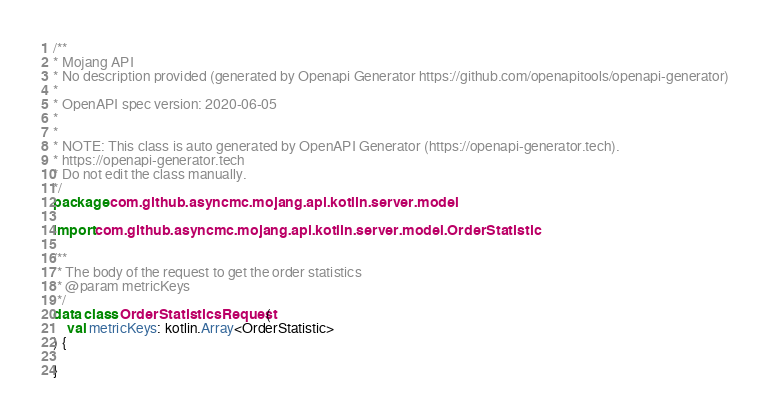Convert code to text. <code><loc_0><loc_0><loc_500><loc_500><_Kotlin_>/**
* Mojang API
* No description provided (generated by Openapi Generator https://github.com/openapitools/openapi-generator)
*
* OpenAPI spec version: 2020-06-05
* 
*
* NOTE: This class is auto generated by OpenAPI Generator (https://openapi-generator.tech).
* https://openapi-generator.tech
* Do not edit the class manually.
*/
package com.github.asyncmc.mojang.api.kotlin.server.model

import com.github.asyncmc.mojang.api.kotlin.server.model.OrderStatistic

/**
 * The body of the request to get the order statistics
 * @param metricKeys 
 */
data class OrderStatisticsRequest (
    val metricKeys: kotlin.Array<OrderStatistic>
) {

}

</code> 